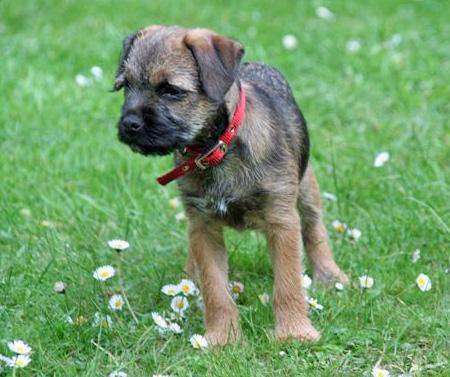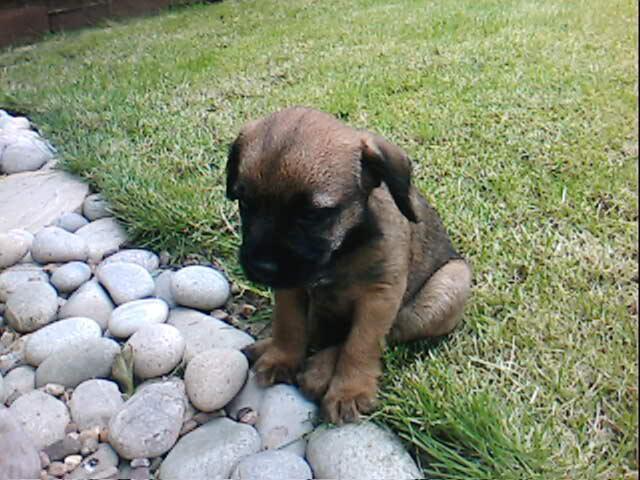The first image is the image on the left, the second image is the image on the right. For the images displayed, is the sentence "In one of the two images, the dog is displaying his tongue." factually correct? Answer yes or no. No. 